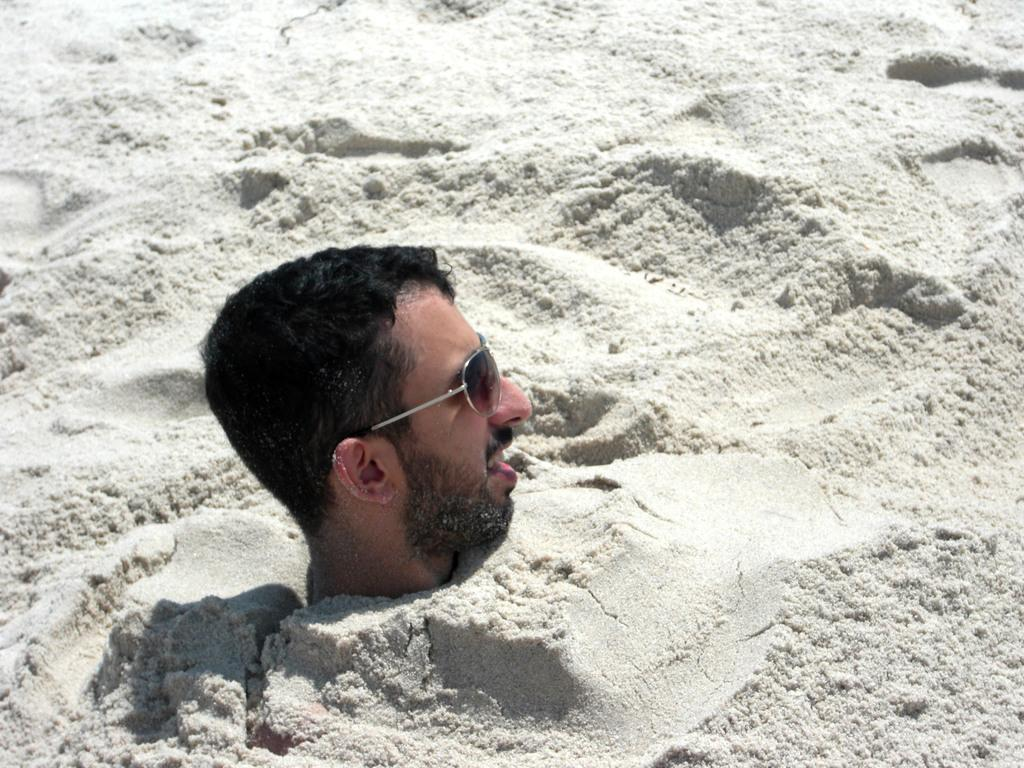Who is present in the image? There is a man in the image. What is the man doing in the image? The man is buried in the sand, with his head out of the sand. What accessory is the man wearing in the image? He is wearing sunglasses. What is the man learning in the image? There is no indication in the image that the man is learning anything. What is the position of the rain in the image? There is no rain present in the image. 